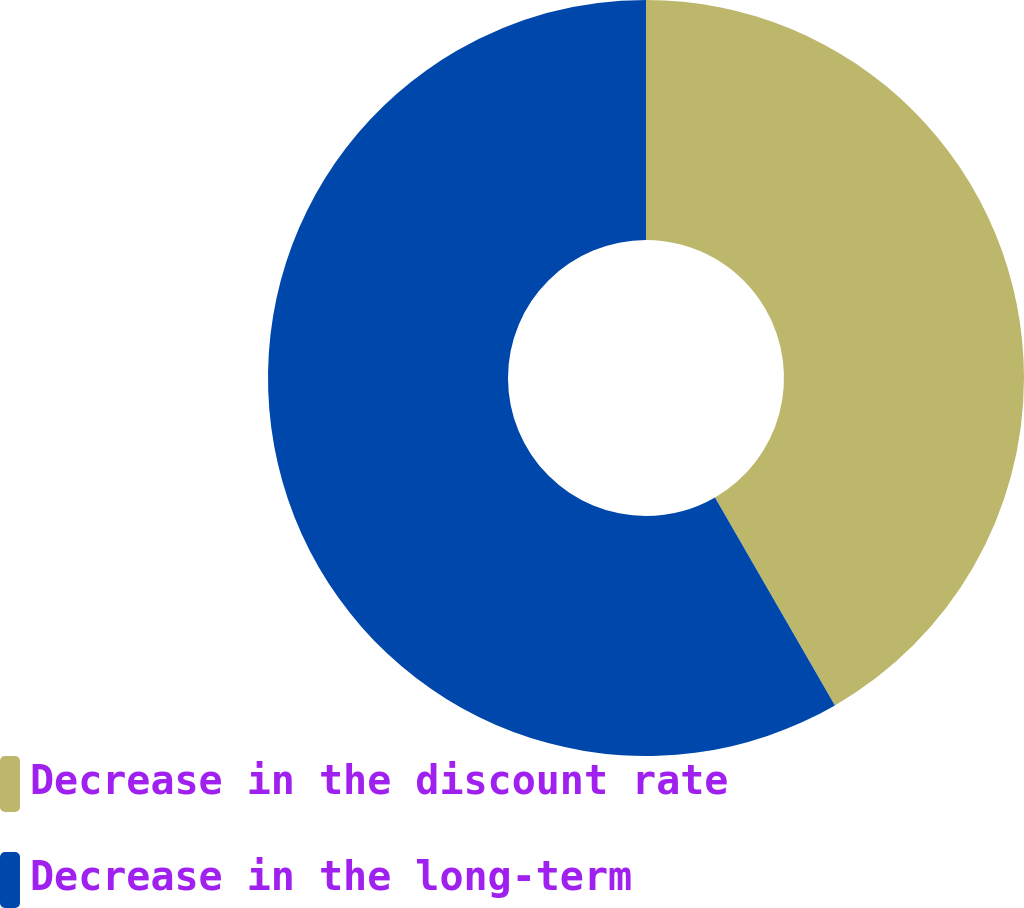<chart> <loc_0><loc_0><loc_500><loc_500><pie_chart><fcel>Decrease in the discount rate<fcel>Decrease in the long-term<nl><fcel>41.67%<fcel>58.33%<nl></chart> 